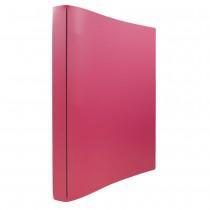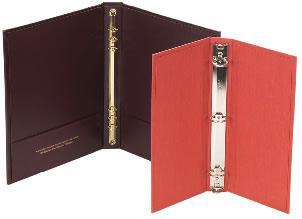The first image is the image on the left, the second image is the image on the right. Given the left and right images, does the statement "The left image contains at least two binders." hold true? Answer yes or no. No. The first image is the image on the left, the second image is the image on the right. Given the left and right images, does the statement "There are fewer than four binders in total." hold true? Answer yes or no. Yes. 